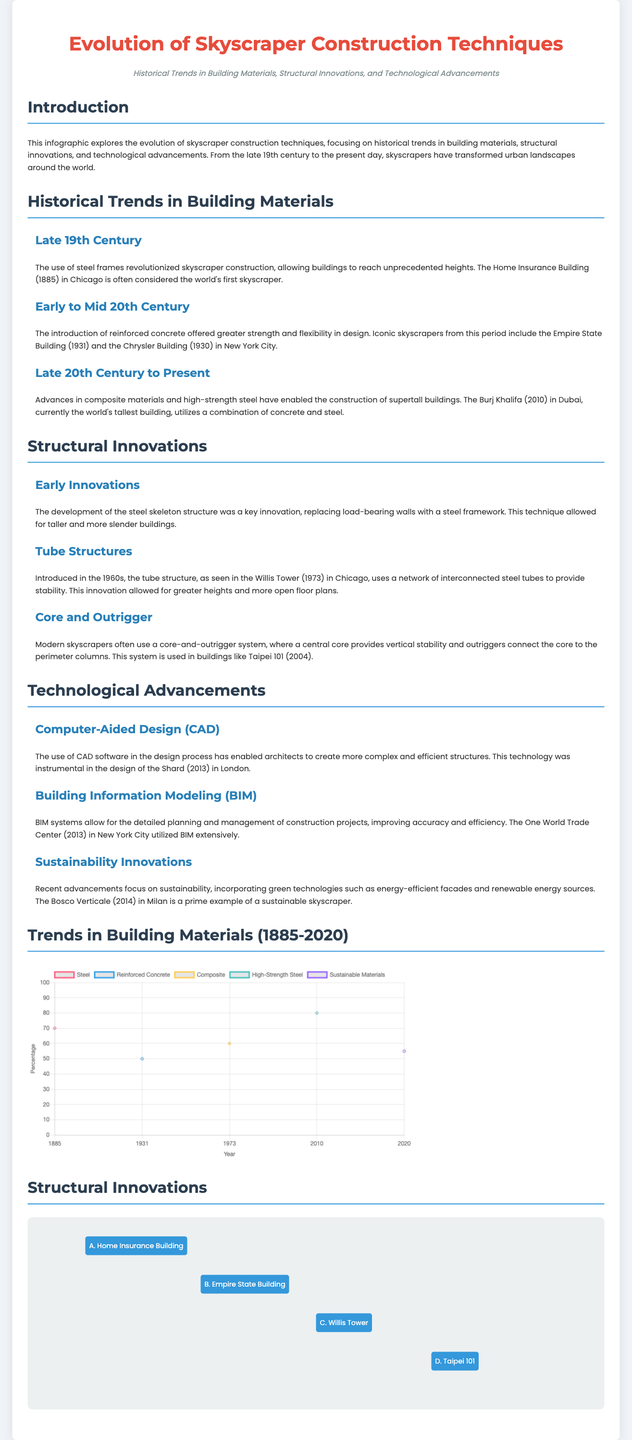What is the title of the infographic? The title of the infographic is prominently displayed at the top, summarizing the main subject matter.
Answer: Evolution of Skyscraper Construction Techniques What year marks the introduction of reinforced concrete in skyscraper construction? The document mentions specific periods for building materials and their innovations, highlighting when reinforced concrete was used.
Answer: Early to Mid 20th Century Which skyscraper is considered the world's first skyscraper? The document identifies a specific building from the late 19th century that is referred to as the first skyscraper.
Answer: Home Insurance Building What percentage of composite materials was used around 1973? The infographic provides specific data points related to material usage over time, including the percentage of composite materials used in that year.
Answer: 60 What is the primary innovation introduced in the 1960s? The document discusses key innovations for skyscraper structures and highlights a significant development that emerged during this decade.
Answer: Tube structures Which skyscraper utilized Building Information Modeling extensively? The document lists examples of buildings that implemented advanced technologies, identifying a specific skyscraper known for its use of BIM.
Answer: One World Trade Center What year did Burj Khalifa complete its construction? The infographic explicitly states the completion year of the world's tallest building within its context.
Answer: 2010 What material percentage is indicated for sustainable materials in 2020? The document presents various materials and their usage percentages over time, including for sustainable materials in the specified year.
Answer: 55 